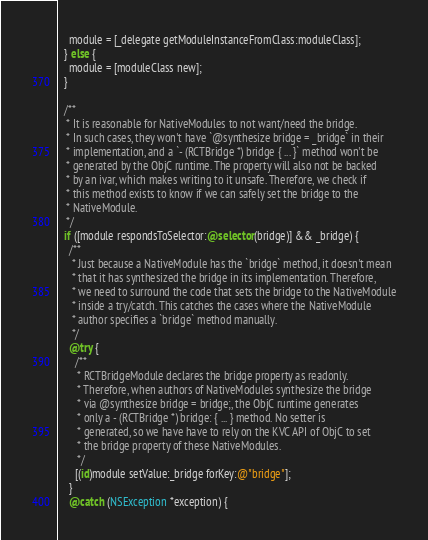<code> <loc_0><loc_0><loc_500><loc_500><_ObjectiveC_>    module = [_delegate getModuleInstanceFromClass:moduleClass];
  } else {
    module = [moduleClass new];
  }

  /**
   * It is reasonable for NativeModules to not want/need the bridge.
   * In such cases, they won't have `@synthesize bridge = _bridge` in their
   * implementation, and a `- (RCTBridge *) bridge { ... }` method won't be
   * generated by the ObjC runtime. The property will also not be backed
   * by an ivar, which makes writing to it unsafe. Therefore, we check if
   * this method exists to know if we can safely set the bridge to the
   * NativeModule.
   */
  if ([module respondsToSelector:@selector(bridge)] && _bridge) {
    /**
     * Just because a NativeModule has the `bridge` method, it doesn't mean
     * that it has synthesized the bridge in its implementation. Therefore,
     * we need to surround the code that sets the bridge to the NativeModule
     * inside a try/catch. This catches the cases where the NativeModule
     * author specifies a `bridge` method manually.
     */
    @try {
      /**
       * RCTBridgeModule declares the bridge property as readonly.
       * Therefore, when authors of NativeModules synthesize the bridge
       * via @synthesize bridge = bridge;, the ObjC runtime generates
       * only a - (RCTBridge *) bridge: { ... } method. No setter is
       * generated, so we have have to rely on the KVC API of ObjC to set
       * the bridge property of these NativeModules.
       */
      [(id)module setValue:_bridge forKey:@"bridge"];
    }
    @catch (NSException *exception) {</code> 